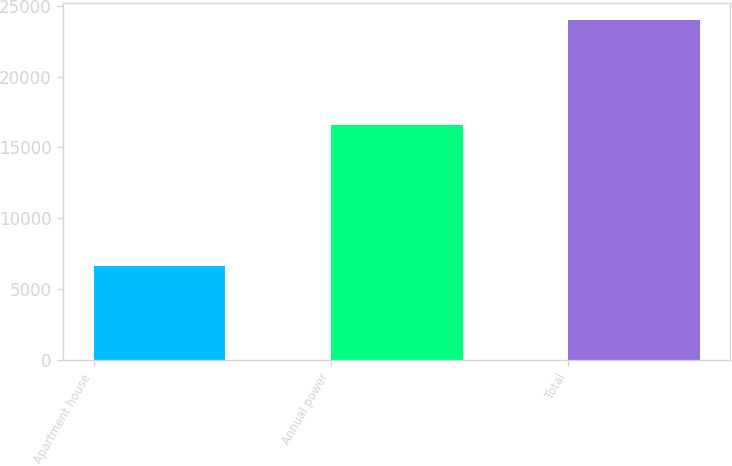Convert chart. <chart><loc_0><loc_0><loc_500><loc_500><bar_chart><fcel>Apartment house<fcel>Annual power<fcel>Total<nl><fcel>6614<fcel>16577<fcel>23976<nl></chart> 